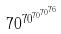<formula> <loc_0><loc_0><loc_500><loc_500>7 0 ^ { 7 0 ^ { 7 0 ^ { 7 0 ^ { 7 6 } } } }</formula> 